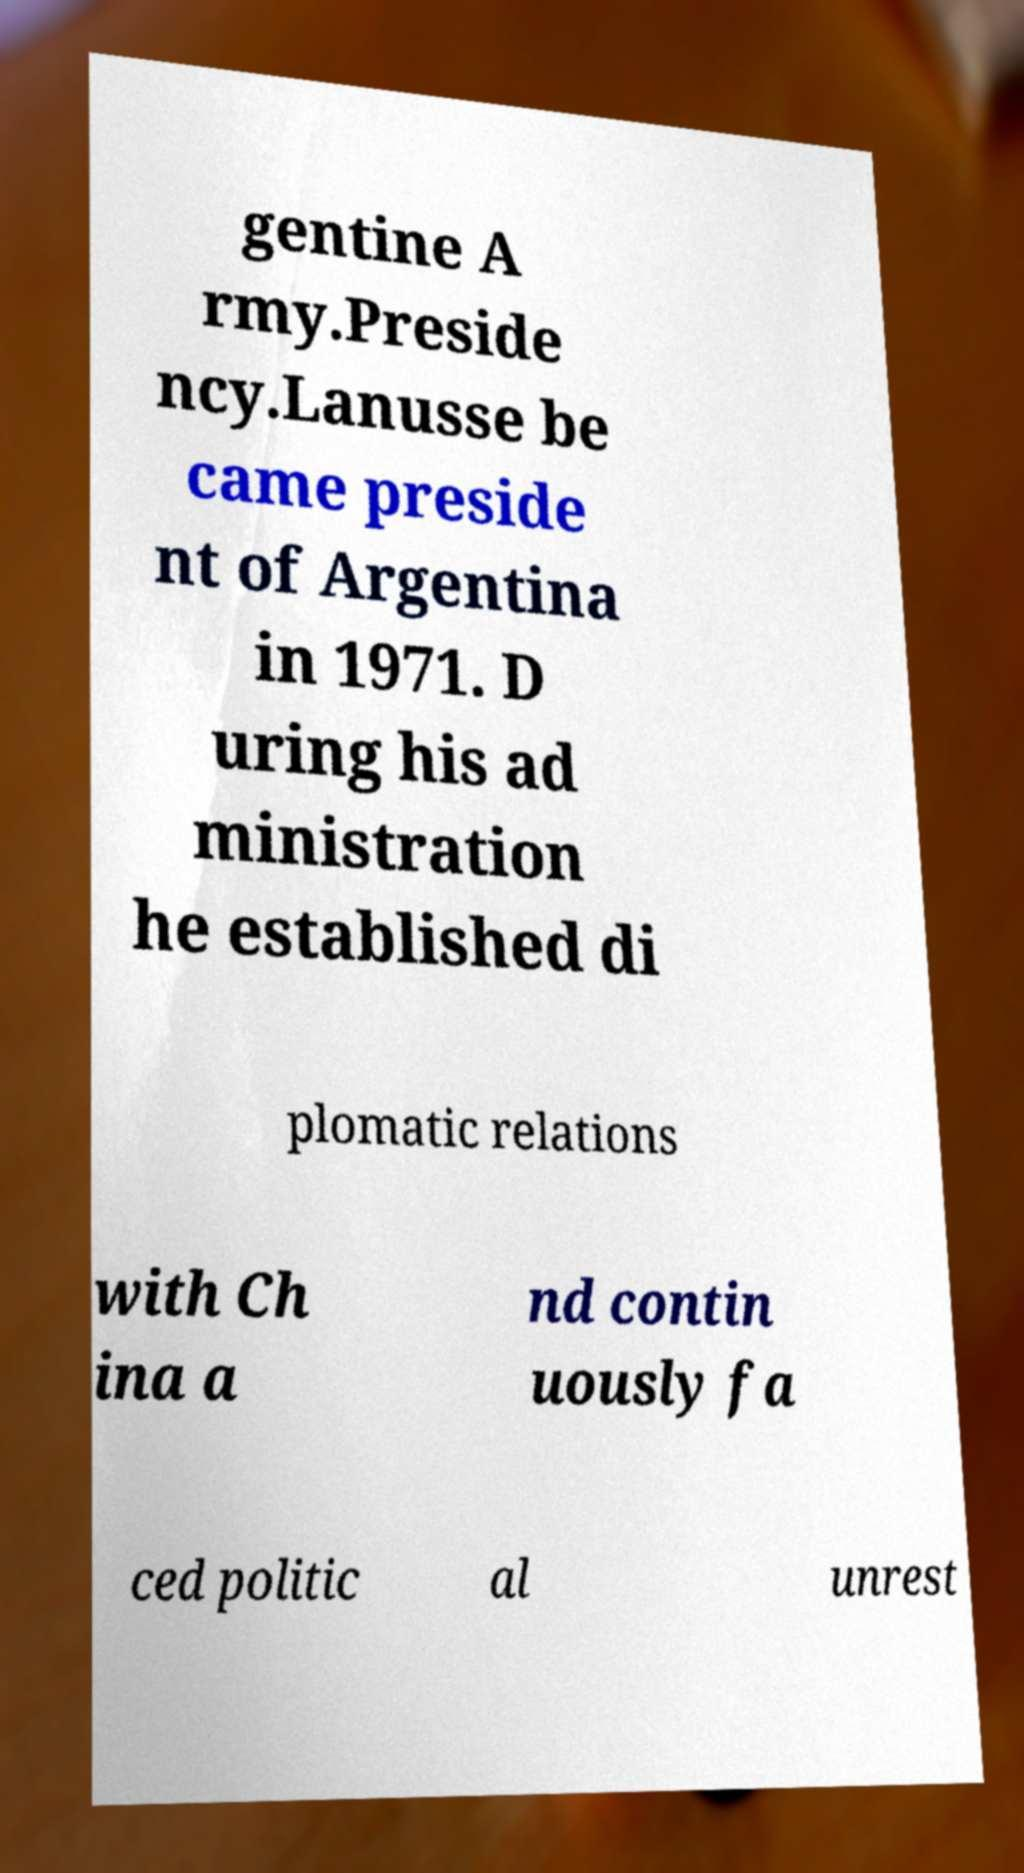Please identify and transcribe the text found in this image. gentine A rmy.Preside ncy.Lanusse be came preside nt of Argentina in 1971. D uring his ad ministration he established di plomatic relations with Ch ina a nd contin uously fa ced politic al unrest 